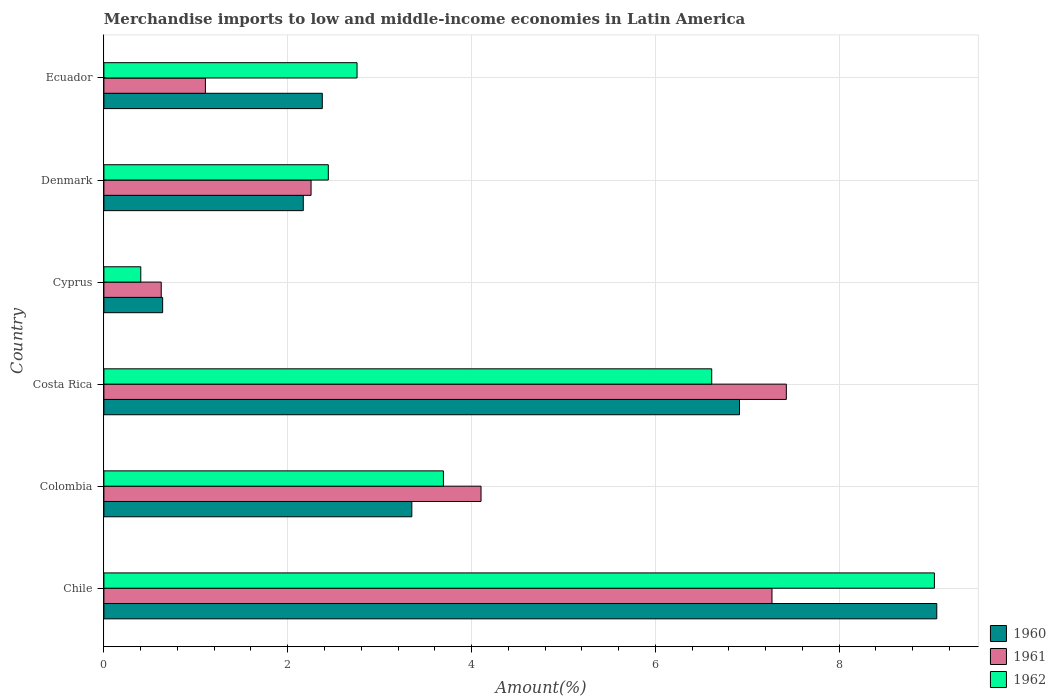How many different coloured bars are there?
Your answer should be compact. 3. How many groups of bars are there?
Your answer should be compact. 6. Are the number of bars on each tick of the Y-axis equal?
Your response must be concise. Yes. How many bars are there on the 3rd tick from the top?
Offer a very short reply. 3. How many bars are there on the 6th tick from the bottom?
Ensure brevity in your answer.  3. What is the label of the 3rd group of bars from the top?
Offer a very short reply. Cyprus. In how many cases, is the number of bars for a given country not equal to the number of legend labels?
Your response must be concise. 0. What is the percentage of amount earned from merchandise imports in 1960 in Denmark?
Your response must be concise. 2.17. Across all countries, what is the maximum percentage of amount earned from merchandise imports in 1961?
Your answer should be compact. 7.42. Across all countries, what is the minimum percentage of amount earned from merchandise imports in 1961?
Make the answer very short. 0.62. In which country was the percentage of amount earned from merchandise imports in 1960 maximum?
Your response must be concise. Chile. In which country was the percentage of amount earned from merchandise imports in 1962 minimum?
Offer a very short reply. Cyprus. What is the total percentage of amount earned from merchandise imports in 1960 in the graph?
Make the answer very short. 24.51. What is the difference between the percentage of amount earned from merchandise imports in 1960 in Chile and that in Cyprus?
Your response must be concise. 8.42. What is the difference between the percentage of amount earned from merchandise imports in 1962 in Denmark and the percentage of amount earned from merchandise imports in 1960 in Chile?
Offer a very short reply. -6.62. What is the average percentage of amount earned from merchandise imports in 1962 per country?
Your response must be concise. 4.16. What is the difference between the percentage of amount earned from merchandise imports in 1960 and percentage of amount earned from merchandise imports in 1961 in Ecuador?
Make the answer very short. 1.27. In how many countries, is the percentage of amount earned from merchandise imports in 1960 greater than 4.8 %?
Your answer should be compact. 2. What is the ratio of the percentage of amount earned from merchandise imports in 1961 in Colombia to that in Ecuador?
Offer a very short reply. 3.72. Is the difference between the percentage of amount earned from merchandise imports in 1960 in Chile and Costa Rica greater than the difference between the percentage of amount earned from merchandise imports in 1961 in Chile and Costa Rica?
Offer a terse response. Yes. What is the difference between the highest and the second highest percentage of amount earned from merchandise imports in 1961?
Your answer should be compact. 0.16. What is the difference between the highest and the lowest percentage of amount earned from merchandise imports in 1960?
Provide a succinct answer. 8.42. What does the 3rd bar from the bottom in Cyprus represents?
Ensure brevity in your answer.  1962. Is it the case that in every country, the sum of the percentage of amount earned from merchandise imports in 1960 and percentage of amount earned from merchandise imports in 1961 is greater than the percentage of amount earned from merchandise imports in 1962?
Offer a very short reply. Yes. Are all the bars in the graph horizontal?
Your answer should be very brief. Yes. How many countries are there in the graph?
Offer a terse response. 6. What is the difference between two consecutive major ticks on the X-axis?
Give a very brief answer. 2. How are the legend labels stacked?
Offer a very short reply. Vertical. What is the title of the graph?
Offer a very short reply. Merchandise imports to low and middle-income economies in Latin America. What is the label or title of the X-axis?
Offer a terse response. Amount(%). What is the Amount(%) of 1960 in Chile?
Offer a very short reply. 9.06. What is the Amount(%) in 1961 in Chile?
Make the answer very short. 7.27. What is the Amount(%) of 1962 in Chile?
Your answer should be compact. 9.04. What is the Amount(%) in 1960 in Colombia?
Your response must be concise. 3.35. What is the Amount(%) of 1961 in Colombia?
Your answer should be very brief. 4.1. What is the Amount(%) in 1962 in Colombia?
Your answer should be compact. 3.69. What is the Amount(%) of 1960 in Costa Rica?
Keep it short and to the point. 6.92. What is the Amount(%) in 1961 in Costa Rica?
Provide a succinct answer. 7.42. What is the Amount(%) in 1962 in Costa Rica?
Keep it short and to the point. 6.61. What is the Amount(%) in 1960 in Cyprus?
Your response must be concise. 0.64. What is the Amount(%) of 1961 in Cyprus?
Provide a succinct answer. 0.62. What is the Amount(%) of 1962 in Cyprus?
Your answer should be compact. 0.4. What is the Amount(%) in 1960 in Denmark?
Your answer should be very brief. 2.17. What is the Amount(%) in 1961 in Denmark?
Your answer should be compact. 2.25. What is the Amount(%) in 1962 in Denmark?
Provide a short and direct response. 2.44. What is the Amount(%) in 1960 in Ecuador?
Your answer should be very brief. 2.38. What is the Amount(%) of 1961 in Ecuador?
Offer a terse response. 1.1. What is the Amount(%) of 1962 in Ecuador?
Make the answer very short. 2.75. Across all countries, what is the maximum Amount(%) of 1960?
Keep it short and to the point. 9.06. Across all countries, what is the maximum Amount(%) of 1961?
Your answer should be compact. 7.42. Across all countries, what is the maximum Amount(%) in 1962?
Offer a terse response. 9.04. Across all countries, what is the minimum Amount(%) of 1960?
Give a very brief answer. 0.64. Across all countries, what is the minimum Amount(%) in 1961?
Your response must be concise. 0.62. Across all countries, what is the minimum Amount(%) in 1962?
Your answer should be compact. 0.4. What is the total Amount(%) of 1960 in the graph?
Your answer should be compact. 24.51. What is the total Amount(%) in 1961 in the graph?
Provide a short and direct response. 22.78. What is the total Amount(%) of 1962 in the graph?
Offer a very short reply. 24.94. What is the difference between the Amount(%) in 1960 in Chile and that in Colombia?
Make the answer very short. 5.71. What is the difference between the Amount(%) of 1961 in Chile and that in Colombia?
Provide a short and direct response. 3.17. What is the difference between the Amount(%) in 1962 in Chile and that in Colombia?
Offer a terse response. 5.34. What is the difference between the Amount(%) in 1960 in Chile and that in Costa Rica?
Make the answer very short. 2.15. What is the difference between the Amount(%) in 1961 in Chile and that in Costa Rica?
Keep it short and to the point. -0.16. What is the difference between the Amount(%) in 1962 in Chile and that in Costa Rica?
Your response must be concise. 2.42. What is the difference between the Amount(%) of 1960 in Chile and that in Cyprus?
Your answer should be compact. 8.42. What is the difference between the Amount(%) in 1961 in Chile and that in Cyprus?
Offer a terse response. 6.64. What is the difference between the Amount(%) of 1962 in Chile and that in Cyprus?
Provide a succinct answer. 8.63. What is the difference between the Amount(%) of 1960 in Chile and that in Denmark?
Offer a terse response. 6.89. What is the difference between the Amount(%) in 1961 in Chile and that in Denmark?
Give a very brief answer. 5.01. What is the difference between the Amount(%) in 1962 in Chile and that in Denmark?
Ensure brevity in your answer.  6.59. What is the difference between the Amount(%) in 1960 in Chile and that in Ecuador?
Provide a succinct answer. 6.69. What is the difference between the Amount(%) in 1961 in Chile and that in Ecuador?
Your answer should be very brief. 6.16. What is the difference between the Amount(%) in 1962 in Chile and that in Ecuador?
Offer a terse response. 6.28. What is the difference between the Amount(%) in 1960 in Colombia and that in Costa Rica?
Provide a succinct answer. -3.57. What is the difference between the Amount(%) of 1961 in Colombia and that in Costa Rica?
Provide a short and direct response. -3.32. What is the difference between the Amount(%) of 1962 in Colombia and that in Costa Rica?
Ensure brevity in your answer.  -2.92. What is the difference between the Amount(%) of 1960 in Colombia and that in Cyprus?
Ensure brevity in your answer.  2.71. What is the difference between the Amount(%) of 1961 in Colombia and that in Cyprus?
Provide a succinct answer. 3.48. What is the difference between the Amount(%) of 1962 in Colombia and that in Cyprus?
Give a very brief answer. 3.29. What is the difference between the Amount(%) of 1960 in Colombia and that in Denmark?
Your response must be concise. 1.18. What is the difference between the Amount(%) of 1961 in Colombia and that in Denmark?
Ensure brevity in your answer.  1.85. What is the difference between the Amount(%) in 1962 in Colombia and that in Denmark?
Keep it short and to the point. 1.25. What is the difference between the Amount(%) of 1961 in Colombia and that in Ecuador?
Your answer should be compact. 3. What is the difference between the Amount(%) in 1962 in Colombia and that in Ecuador?
Provide a short and direct response. 0.94. What is the difference between the Amount(%) of 1960 in Costa Rica and that in Cyprus?
Offer a terse response. 6.28. What is the difference between the Amount(%) in 1961 in Costa Rica and that in Cyprus?
Give a very brief answer. 6.8. What is the difference between the Amount(%) of 1962 in Costa Rica and that in Cyprus?
Your response must be concise. 6.21. What is the difference between the Amount(%) in 1960 in Costa Rica and that in Denmark?
Ensure brevity in your answer.  4.75. What is the difference between the Amount(%) in 1961 in Costa Rica and that in Denmark?
Provide a short and direct response. 5.17. What is the difference between the Amount(%) in 1962 in Costa Rica and that in Denmark?
Your answer should be compact. 4.17. What is the difference between the Amount(%) of 1960 in Costa Rica and that in Ecuador?
Provide a short and direct response. 4.54. What is the difference between the Amount(%) of 1961 in Costa Rica and that in Ecuador?
Your answer should be very brief. 6.32. What is the difference between the Amount(%) of 1962 in Costa Rica and that in Ecuador?
Provide a succinct answer. 3.86. What is the difference between the Amount(%) of 1960 in Cyprus and that in Denmark?
Provide a short and direct response. -1.53. What is the difference between the Amount(%) in 1961 in Cyprus and that in Denmark?
Offer a terse response. -1.63. What is the difference between the Amount(%) in 1962 in Cyprus and that in Denmark?
Provide a succinct answer. -2.04. What is the difference between the Amount(%) in 1960 in Cyprus and that in Ecuador?
Your answer should be compact. -1.74. What is the difference between the Amount(%) in 1961 in Cyprus and that in Ecuador?
Make the answer very short. -0.48. What is the difference between the Amount(%) in 1962 in Cyprus and that in Ecuador?
Keep it short and to the point. -2.35. What is the difference between the Amount(%) in 1960 in Denmark and that in Ecuador?
Offer a terse response. -0.21. What is the difference between the Amount(%) of 1961 in Denmark and that in Ecuador?
Your response must be concise. 1.15. What is the difference between the Amount(%) of 1962 in Denmark and that in Ecuador?
Give a very brief answer. -0.31. What is the difference between the Amount(%) of 1960 in Chile and the Amount(%) of 1961 in Colombia?
Your answer should be very brief. 4.96. What is the difference between the Amount(%) in 1960 in Chile and the Amount(%) in 1962 in Colombia?
Provide a short and direct response. 5.37. What is the difference between the Amount(%) of 1961 in Chile and the Amount(%) of 1962 in Colombia?
Provide a short and direct response. 3.57. What is the difference between the Amount(%) in 1960 in Chile and the Amount(%) in 1961 in Costa Rica?
Your answer should be compact. 1.64. What is the difference between the Amount(%) of 1960 in Chile and the Amount(%) of 1962 in Costa Rica?
Make the answer very short. 2.45. What is the difference between the Amount(%) in 1961 in Chile and the Amount(%) in 1962 in Costa Rica?
Your answer should be very brief. 0.66. What is the difference between the Amount(%) of 1960 in Chile and the Amount(%) of 1961 in Cyprus?
Keep it short and to the point. 8.44. What is the difference between the Amount(%) in 1960 in Chile and the Amount(%) in 1962 in Cyprus?
Keep it short and to the point. 8.66. What is the difference between the Amount(%) in 1961 in Chile and the Amount(%) in 1962 in Cyprus?
Keep it short and to the point. 6.87. What is the difference between the Amount(%) of 1960 in Chile and the Amount(%) of 1961 in Denmark?
Provide a succinct answer. 6.81. What is the difference between the Amount(%) of 1960 in Chile and the Amount(%) of 1962 in Denmark?
Offer a terse response. 6.62. What is the difference between the Amount(%) in 1961 in Chile and the Amount(%) in 1962 in Denmark?
Give a very brief answer. 4.83. What is the difference between the Amount(%) in 1960 in Chile and the Amount(%) in 1961 in Ecuador?
Give a very brief answer. 7.96. What is the difference between the Amount(%) in 1960 in Chile and the Amount(%) in 1962 in Ecuador?
Offer a very short reply. 6.31. What is the difference between the Amount(%) of 1961 in Chile and the Amount(%) of 1962 in Ecuador?
Your response must be concise. 4.51. What is the difference between the Amount(%) in 1960 in Colombia and the Amount(%) in 1961 in Costa Rica?
Offer a terse response. -4.07. What is the difference between the Amount(%) in 1960 in Colombia and the Amount(%) in 1962 in Costa Rica?
Give a very brief answer. -3.26. What is the difference between the Amount(%) in 1961 in Colombia and the Amount(%) in 1962 in Costa Rica?
Your answer should be very brief. -2.51. What is the difference between the Amount(%) in 1960 in Colombia and the Amount(%) in 1961 in Cyprus?
Provide a short and direct response. 2.73. What is the difference between the Amount(%) of 1960 in Colombia and the Amount(%) of 1962 in Cyprus?
Your answer should be compact. 2.95. What is the difference between the Amount(%) in 1961 in Colombia and the Amount(%) in 1962 in Cyprus?
Keep it short and to the point. 3.7. What is the difference between the Amount(%) in 1960 in Colombia and the Amount(%) in 1961 in Denmark?
Your answer should be compact. 1.1. What is the difference between the Amount(%) of 1960 in Colombia and the Amount(%) of 1962 in Denmark?
Your response must be concise. 0.91. What is the difference between the Amount(%) of 1961 in Colombia and the Amount(%) of 1962 in Denmark?
Ensure brevity in your answer.  1.66. What is the difference between the Amount(%) in 1960 in Colombia and the Amount(%) in 1961 in Ecuador?
Give a very brief answer. 2.25. What is the difference between the Amount(%) of 1960 in Colombia and the Amount(%) of 1962 in Ecuador?
Ensure brevity in your answer.  0.6. What is the difference between the Amount(%) of 1961 in Colombia and the Amount(%) of 1962 in Ecuador?
Ensure brevity in your answer.  1.35. What is the difference between the Amount(%) in 1960 in Costa Rica and the Amount(%) in 1961 in Cyprus?
Provide a short and direct response. 6.29. What is the difference between the Amount(%) in 1960 in Costa Rica and the Amount(%) in 1962 in Cyprus?
Keep it short and to the point. 6.51. What is the difference between the Amount(%) in 1961 in Costa Rica and the Amount(%) in 1962 in Cyprus?
Your answer should be compact. 7.02. What is the difference between the Amount(%) of 1960 in Costa Rica and the Amount(%) of 1961 in Denmark?
Provide a succinct answer. 4.66. What is the difference between the Amount(%) of 1960 in Costa Rica and the Amount(%) of 1962 in Denmark?
Ensure brevity in your answer.  4.47. What is the difference between the Amount(%) in 1961 in Costa Rica and the Amount(%) in 1962 in Denmark?
Provide a short and direct response. 4.98. What is the difference between the Amount(%) in 1960 in Costa Rica and the Amount(%) in 1961 in Ecuador?
Offer a terse response. 5.81. What is the difference between the Amount(%) in 1960 in Costa Rica and the Amount(%) in 1962 in Ecuador?
Your response must be concise. 4.16. What is the difference between the Amount(%) of 1961 in Costa Rica and the Amount(%) of 1962 in Ecuador?
Make the answer very short. 4.67. What is the difference between the Amount(%) of 1960 in Cyprus and the Amount(%) of 1961 in Denmark?
Make the answer very short. -1.61. What is the difference between the Amount(%) in 1960 in Cyprus and the Amount(%) in 1962 in Denmark?
Your response must be concise. -1.8. What is the difference between the Amount(%) in 1961 in Cyprus and the Amount(%) in 1962 in Denmark?
Make the answer very short. -1.82. What is the difference between the Amount(%) in 1960 in Cyprus and the Amount(%) in 1961 in Ecuador?
Ensure brevity in your answer.  -0.47. What is the difference between the Amount(%) in 1960 in Cyprus and the Amount(%) in 1962 in Ecuador?
Your response must be concise. -2.12. What is the difference between the Amount(%) in 1961 in Cyprus and the Amount(%) in 1962 in Ecuador?
Offer a very short reply. -2.13. What is the difference between the Amount(%) in 1960 in Denmark and the Amount(%) in 1961 in Ecuador?
Provide a succinct answer. 1.07. What is the difference between the Amount(%) of 1960 in Denmark and the Amount(%) of 1962 in Ecuador?
Your answer should be very brief. -0.58. What is the difference between the Amount(%) of 1961 in Denmark and the Amount(%) of 1962 in Ecuador?
Your answer should be compact. -0.5. What is the average Amount(%) in 1960 per country?
Your answer should be compact. 4.09. What is the average Amount(%) of 1961 per country?
Your answer should be very brief. 3.8. What is the average Amount(%) of 1962 per country?
Offer a terse response. 4.16. What is the difference between the Amount(%) of 1960 and Amount(%) of 1961 in Chile?
Provide a succinct answer. 1.79. What is the difference between the Amount(%) in 1960 and Amount(%) in 1962 in Chile?
Give a very brief answer. 0.03. What is the difference between the Amount(%) of 1961 and Amount(%) of 1962 in Chile?
Offer a terse response. -1.77. What is the difference between the Amount(%) of 1960 and Amount(%) of 1961 in Colombia?
Your answer should be very brief. -0.75. What is the difference between the Amount(%) in 1960 and Amount(%) in 1962 in Colombia?
Keep it short and to the point. -0.34. What is the difference between the Amount(%) in 1961 and Amount(%) in 1962 in Colombia?
Offer a terse response. 0.41. What is the difference between the Amount(%) in 1960 and Amount(%) in 1961 in Costa Rica?
Give a very brief answer. -0.51. What is the difference between the Amount(%) in 1960 and Amount(%) in 1962 in Costa Rica?
Give a very brief answer. 0.3. What is the difference between the Amount(%) of 1961 and Amount(%) of 1962 in Costa Rica?
Your answer should be very brief. 0.81. What is the difference between the Amount(%) in 1960 and Amount(%) in 1961 in Cyprus?
Offer a very short reply. 0.02. What is the difference between the Amount(%) of 1960 and Amount(%) of 1962 in Cyprus?
Your answer should be very brief. 0.24. What is the difference between the Amount(%) in 1961 and Amount(%) in 1962 in Cyprus?
Your answer should be very brief. 0.22. What is the difference between the Amount(%) of 1960 and Amount(%) of 1961 in Denmark?
Provide a succinct answer. -0.08. What is the difference between the Amount(%) of 1960 and Amount(%) of 1962 in Denmark?
Offer a terse response. -0.27. What is the difference between the Amount(%) in 1961 and Amount(%) in 1962 in Denmark?
Provide a succinct answer. -0.19. What is the difference between the Amount(%) of 1960 and Amount(%) of 1961 in Ecuador?
Provide a short and direct response. 1.27. What is the difference between the Amount(%) in 1960 and Amount(%) in 1962 in Ecuador?
Your response must be concise. -0.38. What is the difference between the Amount(%) in 1961 and Amount(%) in 1962 in Ecuador?
Your answer should be compact. -1.65. What is the ratio of the Amount(%) of 1960 in Chile to that in Colombia?
Provide a succinct answer. 2.7. What is the ratio of the Amount(%) of 1961 in Chile to that in Colombia?
Keep it short and to the point. 1.77. What is the ratio of the Amount(%) in 1962 in Chile to that in Colombia?
Keep it short and to the point. 2.45. What is the ratio of the Amount(%) in 1960 in Chile to that in Costa Rica?
Your answer should be very brief. 1.31. What is the ratio of the Amount(%) of 1961 in Chile to that in Costa Rica?
Your answer should be compact. 0.98. What is the ratio of the Amount(%) of 1962 in Chile to that in Costa Rica?
Offer a very short reply. 1.37. What is the ratio of the Amount(%) of 1960 in Chile to that in Cyprus?
Your answer should be very brief. 14.18. What is the ratio of the Amount(%) of 1961 in Chile to that in Cyprus?
Keep it short and to the point. 11.65. What is the ratio of the Amount(%) of 1962 in Chile to that in Cyprus?
Ensure brevity in your answer.  22.52. What is the ratio of the Amount(%) of 1960 in Chile to that in Denmark?
Offer a terse response. 4.18. What is the ratio of the Amount(%) in 1961 in Chile to that in Denmark?
Keep it short and to the point. 3.22. What is the ratio of the Amount(%) in 1962 in Chile to that in Denmark?
Provide a succinct answer. 3.7. What is the ratio of the Amount(%) of 1960 in Chile to that in Ecuador?
Offer a terse response. 3.81. What is the ratio of the Amount(%) in 1961 in Chile to that in Ecuador?
Keep it short and to the point. 6.58. What is the ratio of the Amount(%) in 1962 in Chile to that in Ecuador?
Give a very brief answer. 3.28. What is the ratio of the Amount(%) of 1960 in Colombia to that in Costa Rica?
Your answer should be very brief. 0.48. What is the ratio of the Amount(%) in 1961 in Colombia to that in Costa Rica?
Ensure brevity in your answer.  0.55. What is the ratio of the Amount(%) of 1962 in Colombia to that in Costa Rica?
Give a very brief answer. 0.56. What is the ratio of the Amount(%) in 1960 in Colombia to that in Cyprus?
Provide a succinct answer. 5.24. What is the ratio of the Amount(%) in 1961 in Colombia to that in Cyprus?
Provide a short and direct response. 6.58. What is the ratio of the Amount(%) in 1962 in Colombia to that in Cyprus?
Provide a short and direct response. 9.21. What is the ratio of the Amount(%) of 1960 in Colombia to that in Denmark?
Provide a short and direct response. 1.54. What is the ratio of the Amount(%) in 1961 in Colombia to that in Denmark?
Offer a very short reply. 1.82. What is the ratio of the Amount(%) in 1962 in Colombia to that in Denmark?
Give a very brief answer. 1.51. What is the ratio of the Amount(%) of 1960 in Colombia to that in Ecuador?
Provide a succinct answer. 1.41. What is the ratio of the Amount(%) of 1961 in Colombia to that in Ecuador?
Offer a very short reply. 3.72. What is the ratio of the Amount(%) in 1962 in Colombia to that in Ecuador?
Keep it short and to the point. 1.34. What is the ratio of the Amount(%) in 1960 in Costa Rica to that in Cyprus?
Provide a short and direct response. 10.82. What is the ratio of the Amount(%) in 1961 in Costa Rica to that in Cyprus?
Your response must be concise. 11.9. What is the ratio of the Amount(%) in 1962 in Costa Rica to that in Cyprus?
Offer a terse response. 16.48. What is the ratio of the Amount(%) of 1960 in Costa Rica to that in Denmark?
Keep it short and to the point. 3.19. What is the ratio of the Amount(%) in 1961 in Costa Rica to that in Denmark?
Your response must be concise. 3.29. What is the ratio of the Amount(%) of 1962 in Costa Rica to that in Denmark?
Offer a terse response. 2.71. What is the ratio of the Amount(%) in 1960 in Costa Rica to that in Ecuador?
Your answer should be compact. 2.91. What is the ratio of the Amount(%) in 1961 in Costa Rica to that in Ecuador?
Give a very brief answer. 6.72. What is the ratio of the Amount(%) in 1962 in Costa Rica to that in Ecuador?
Make the answer very short. 2.4. What is the ratio of the Amount(%) of 1960 in Cyprus to that in Denmark?
Your response must be concise. 0.29. What is the ratio of the Amount(%) of 1961 in Cyprus to that in Denmark?
Offer a terse response. 0.28. What is the ratio of the Amount(%) of 1962 in Cyprus to that in Denmark?
Your answer should be very brief. 0.16. What is the ratio of the Amount(%) in 1960 in Cyprus to that in Ecuador?
Your answer should be compact. 0.27. What is the ratio of the Amount(%) of 1961 in Cyprus to that in Ecuador?
Your response must be concise. 0.56. What is the ratio of the Amount(%) in 1962 in Cyprus to that in Ecuador?
Offer a terse response. 0.15. What is the ratio of the Amount(%) of 1960 in Denmark to that in Ecuador?
Provide a short and direct response. 0.91. What is the ratio of the Amount(%) of 1961 in Denmark to that in Ecuador?
Your answer should be very brief. 2.04. What is the ratio of the Amount(%) of 1962 in Denmark to that in Ecuador?
Keep it short and to the point. 0.89. What is the difference between the highest and the second highest Amount(%) of 1960?
Make the answer very short. 2.15. What is the difference between the highest and the second highest Amount(%) of 1961?
Provide a succinct answer. 0.16. What is the difference between the highest and the second highest Amount(%) of 1962?
Make the answer very short. 2.42. What is the difference between the highest and the lowest Amount(%) of 1960?
Make the answer very short. 8.42. What is the difference between the highest and the lowest Amount(%) of 1961?
Make the answer very short. 6.8. What is the difference between the highest and the lowest Amount(%) in 1962?
Offer a very short reply. 8.63. 